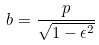<formula> <loc_0><loc_0><loc_500><loc_500>b = \frac { p } { \sqrt { 1 - \epsilon ^ { 2 } } }</formula> 